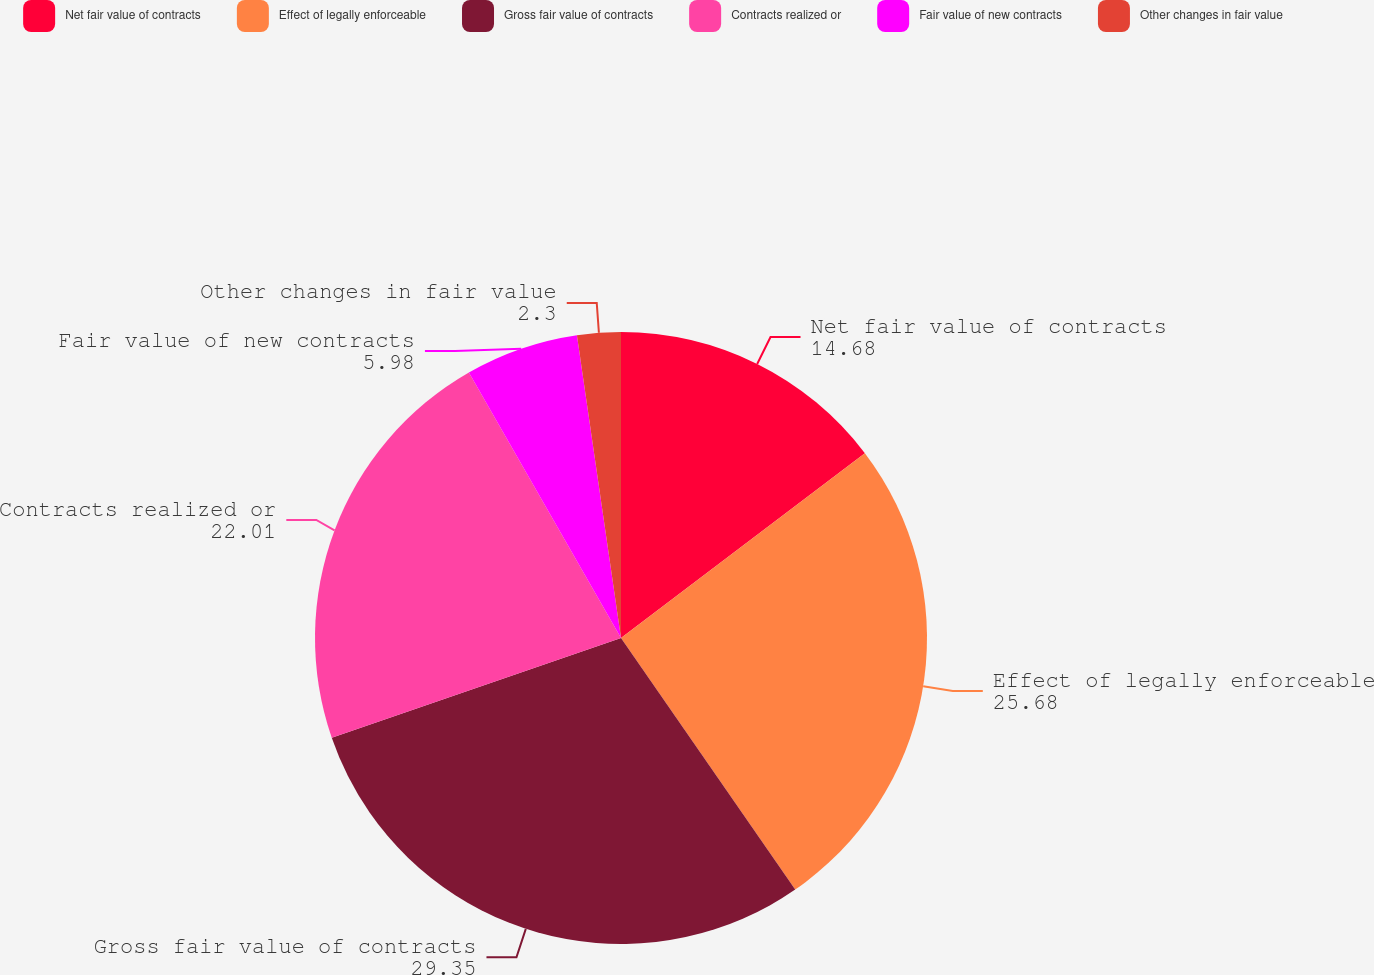Convert chart. <chart><loc_0><loc_0><loc_500><loc_500><pie_chart><fcel>Net fair value of contracts<fcel>Effect of legally enforceable<fcel>Gross fair value of contracts<fcel>Contracts realized or<fcel>Fair value of new contracts<fcel>Other changes in fair value<nl><fcel>14.68%<fcel>25.68%<fcel>29.35%<fcel>22.01%<fcel>5.98%<fcel>2.3%<nl></chart> 